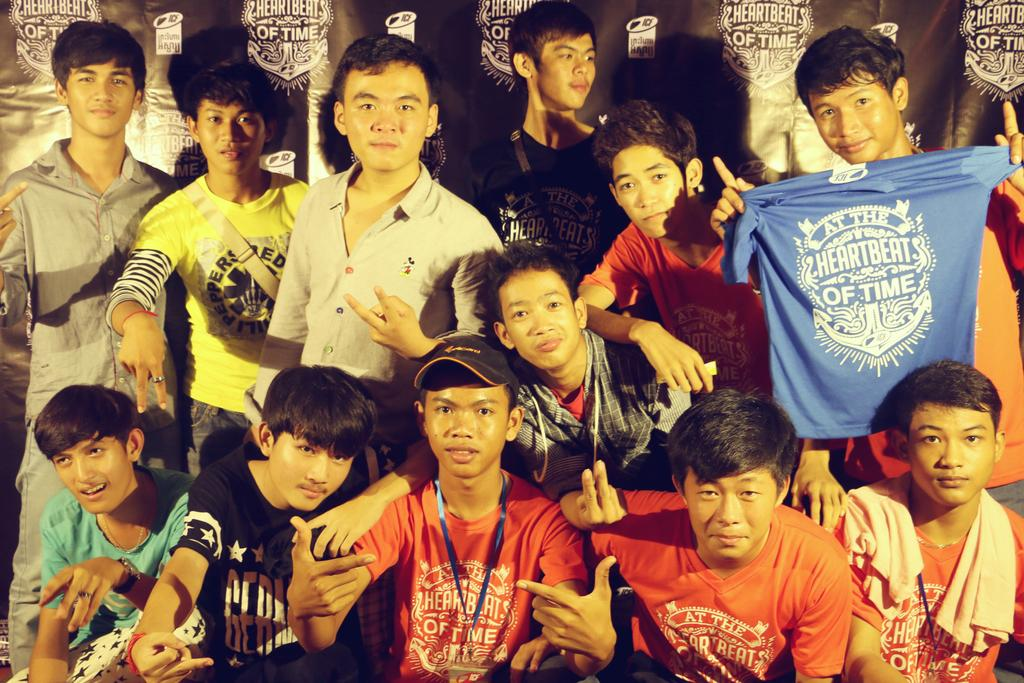What are the boys in the image doing? In the image, there are boys standing and sitting. Can you describe the clothing of one of the boys? One boy is holding a blue color t-shirt. What can be seen in the background of the image? There are black color posters in the background of the image. What type of glue is being used by the boys in the image? There is no glue present in the image; the boys are standing and sitting. Can you tell me how many family members are visible in the image? The image does not show any family members; it only shows boys. 